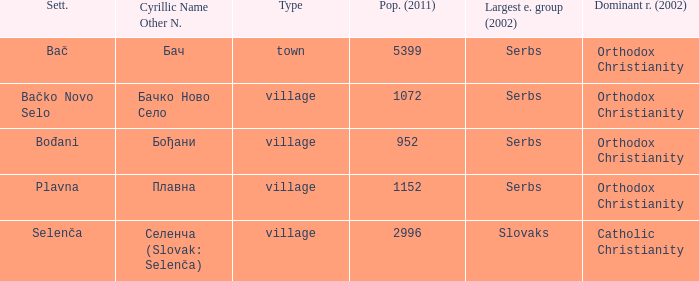What is the second way of writting плавна. Plavna. 